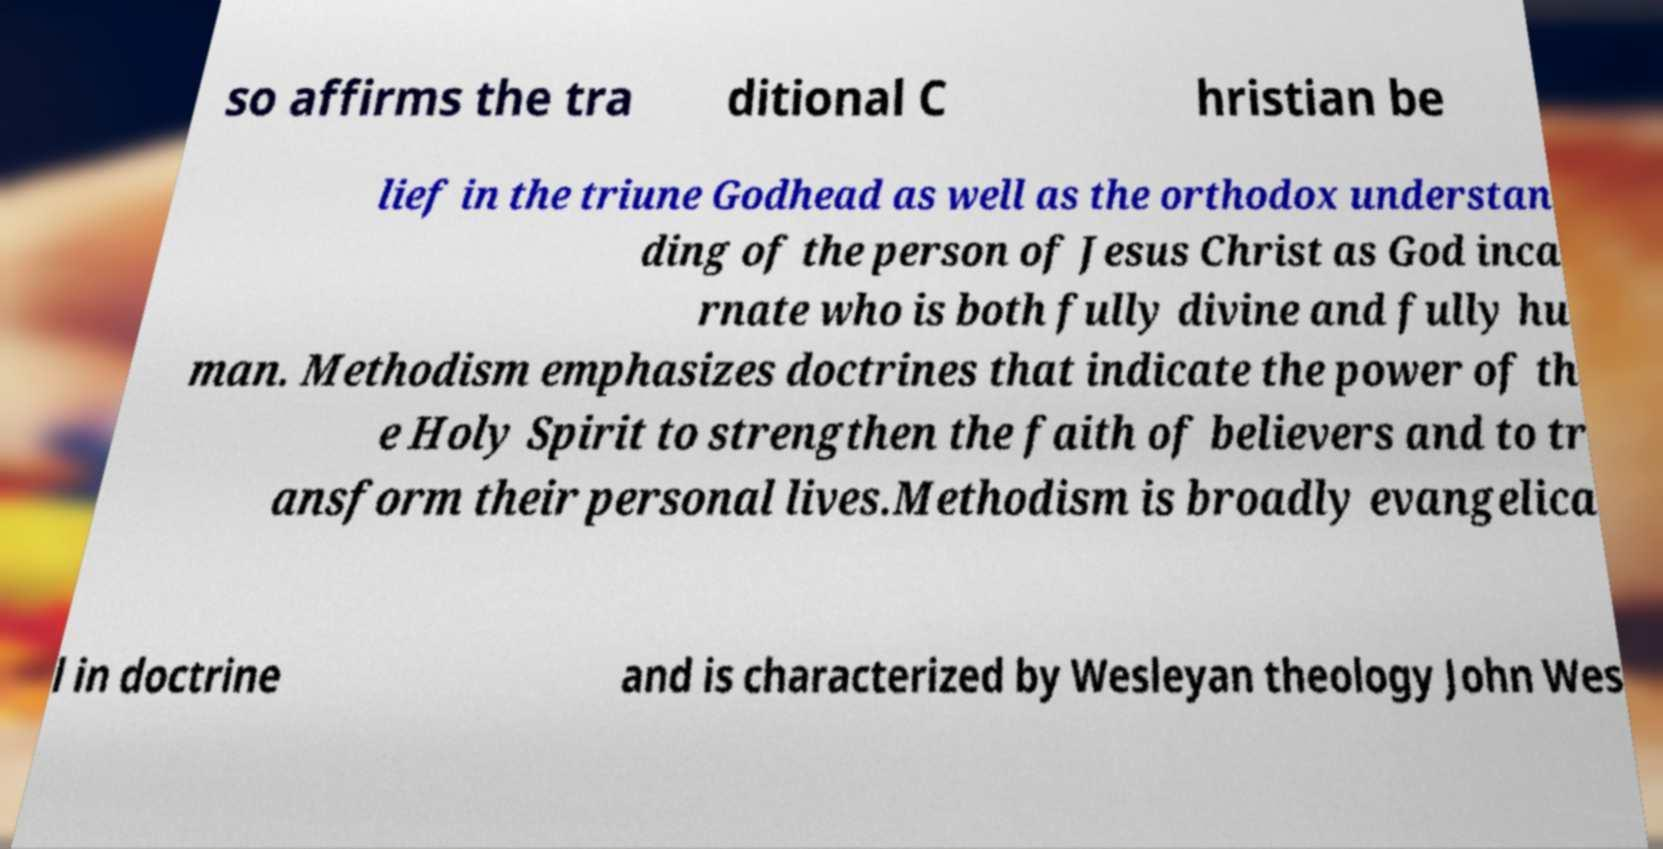There's text embedded in this image that I need extracted. Can you transcribe it verbatim? so affirms the tra ditional C hristian be lief in the triune Godhead as well as the orthodox understan ding of the person of Jesus Christ as God inca rnate who is both fully divine and fully hu man. Methodism emphasizes doctrines that indicate the power of th e Holy Spirit to strengthen the faith of believers and to tr ansform their personal lives.Methodism is broadly evangelica l in doctrine and is characterized by Wesleyan theology John Wes 